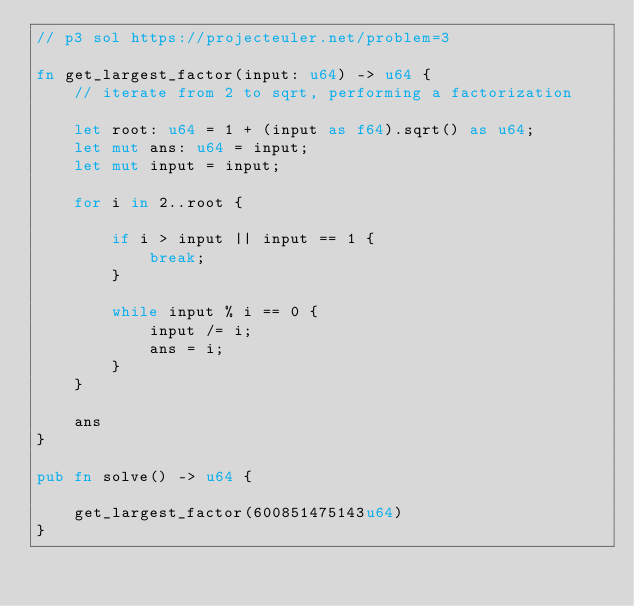Convert code to text. <code><loc_0><loc_0><loc_500><loc_500><_Rust_>// p3 sol https://projecteuler.net/problem=3

fn get_largest_factor(input: u64) -> u64 {
    // iterate from 2 to sqrt, performing a factorization

    let root: u64 = 1 + (input as f64).sqrt() as u64;
    let mut ans: u64 = input;
    let mut input = input;

    for i in 2..root {

        if i > input || input == 1 {
            break;
        }

        while input % i == 0 {
            input /= i;
            ans = i;
        }
    }

    ans
}

pub fn solve() -> u64 {
    
    get_largest_factor(600851475143u64)
}</code> 